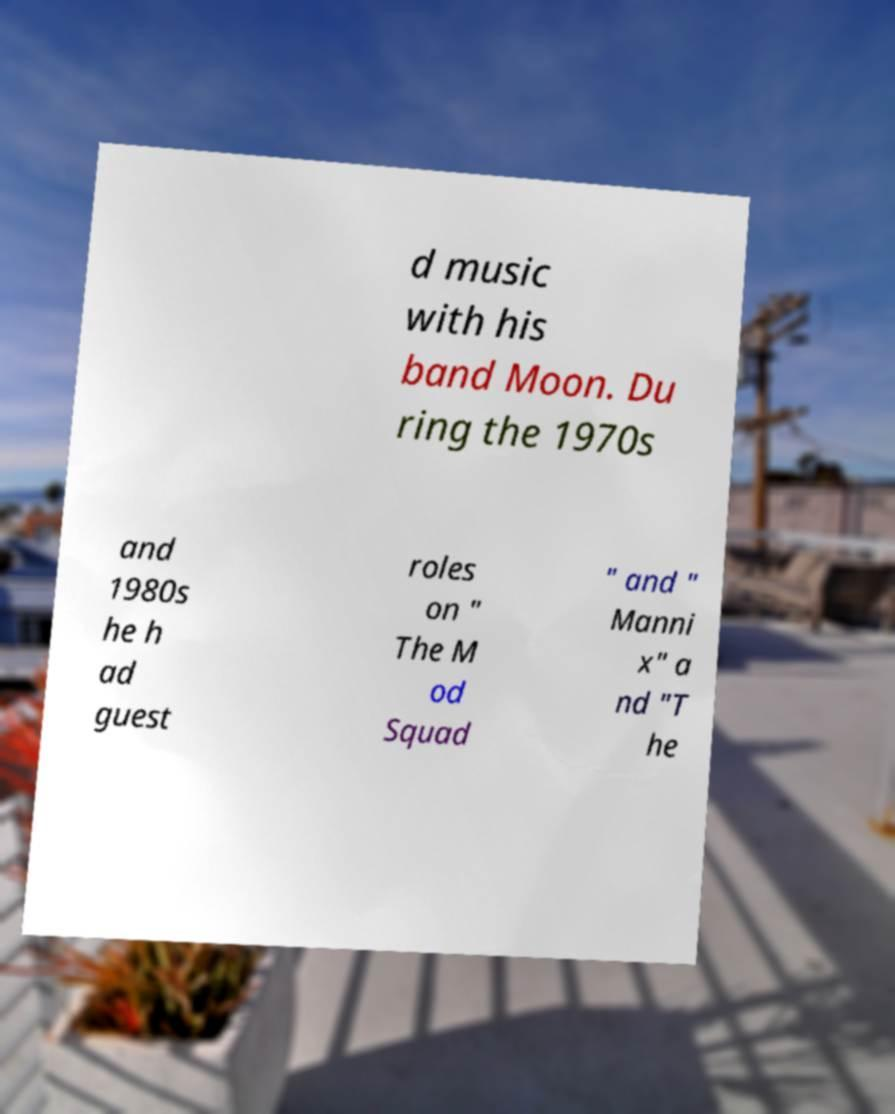Could you assist in decoding the text presented in this image and type it out clearly? d music with his band Moon. Du ring the 1970s and 1980s he h ad guest roles on " The M od Squad " and " Manni x" a nd "T he 